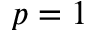Convert formula to latex. <formula><loc_0><loc_0><loc_500><loc_500>p = 1</formula> 